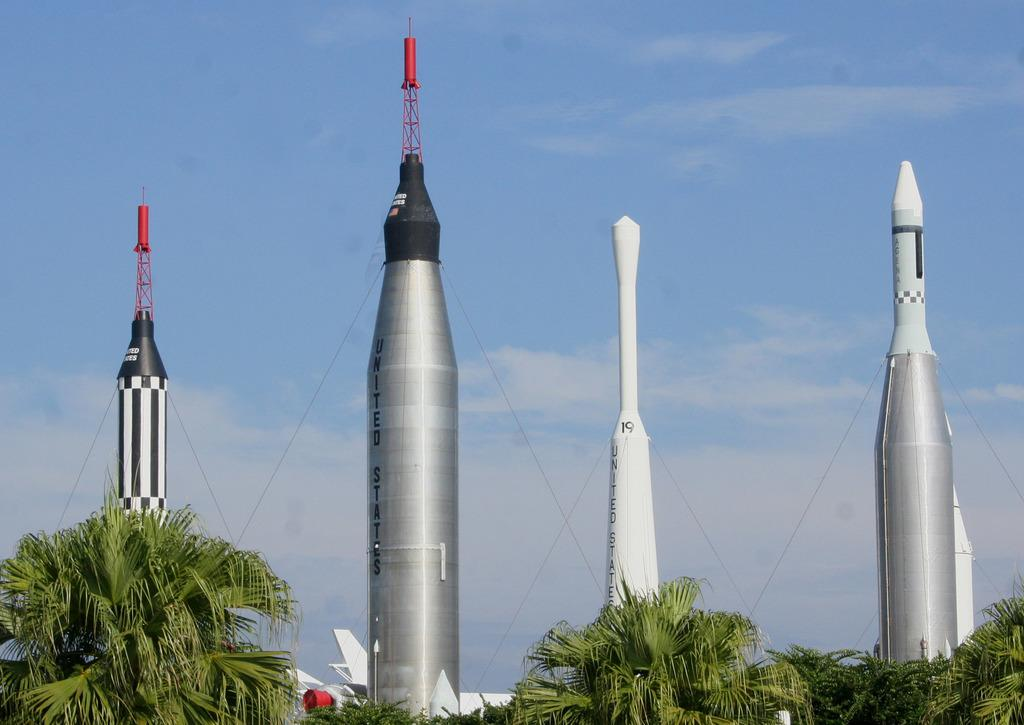What is the main subject of the image? There is a rocket garden in the image. What other elements can be seen in the image? There are trees in the image. How would you describe the sky in the image? The sky is cloudy and pale blue in the image. What type of bottle can be seen on the coast in the image? There is no bottle or coast present in the image; it features a rocket garden and trees. 